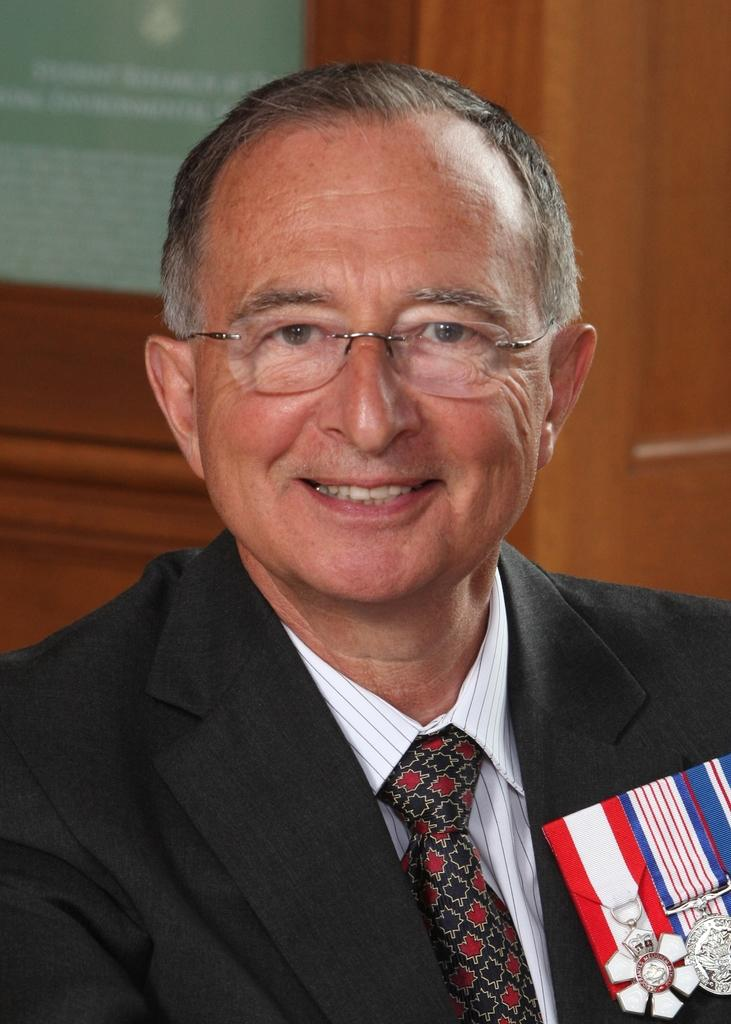Who is the main subject in the image? There is a person in the center of the image. What is the person wearing? The person is wearing a suit. Are there any additional details about the person's attire? Yes, the person has badges on their suit. What can be seen in the background of the image? There is a wooden door in the background of the image. How does the person control the friction in the image? There is no indication in the image that the person is controlling friction, as the image does not depict any objects or situations related to friction. 